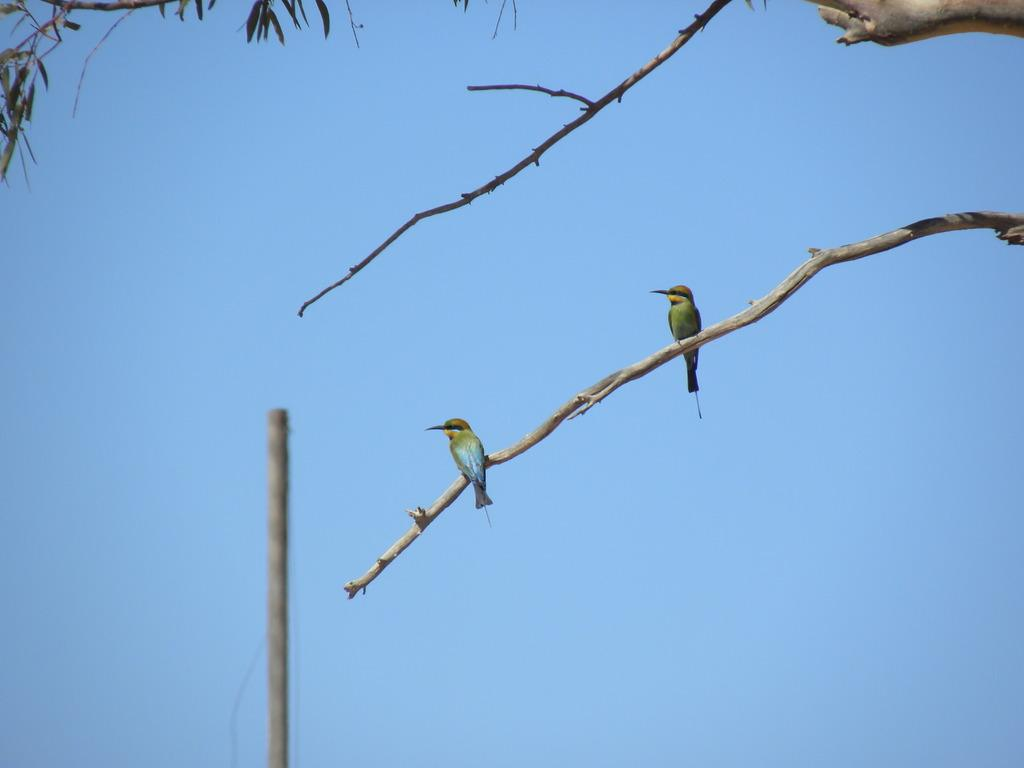What is the main subject in the center of the image? There are branches with leaves in the center of the image. Are there any animals present in the image? Yes, two birds are present on one of the branches. What can be seen in the background of the image? The sky is visible in the background of the image, and there is also a pole present. How much sugar is on the branches in the image? There is no sugar present on the branches in the image; it features branches with leaves and birds. 